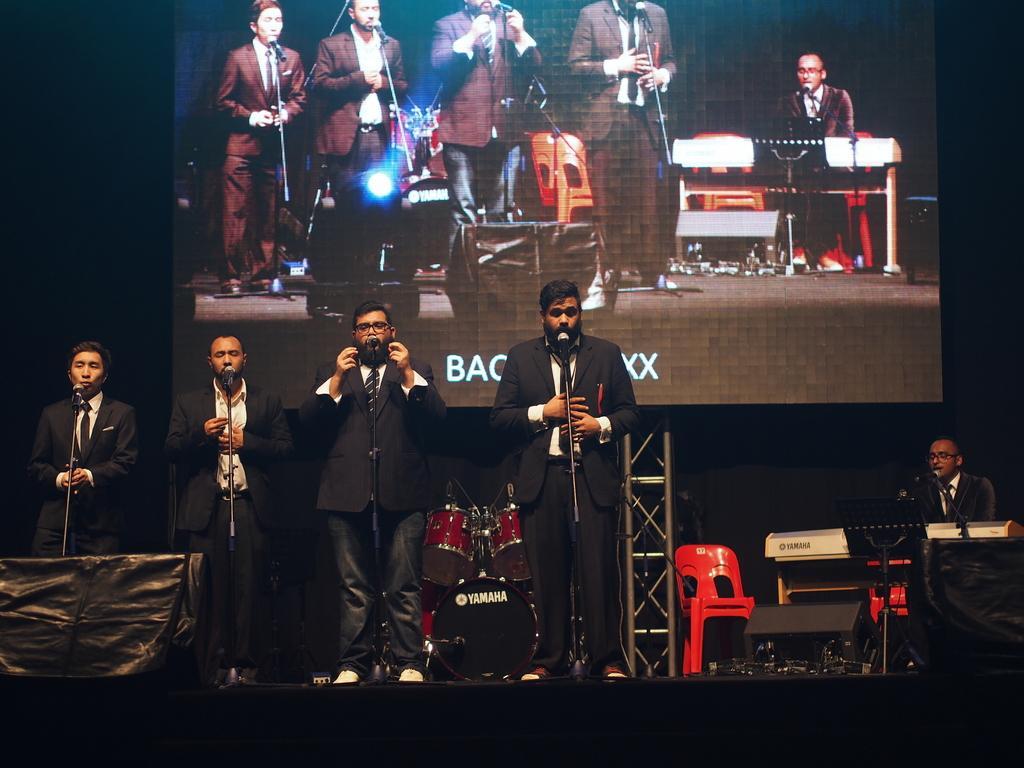How would you summarize this image in a sentence or two? In this image I can see 5 persons where one is sitting and four are standing. I can also see all of them are wearing formal dress and in the front of them I can see mics. In the background I can see a drum set, a chair, a musical instrument and a screen. I can also see two black colour things on the bottom right side and on the bottom left side of this image. 